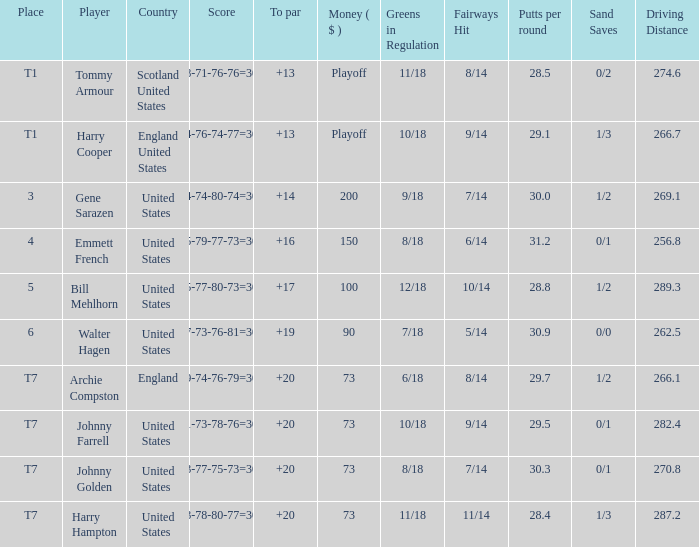What is the ranking for the United States when the money is $200? 3.0. 